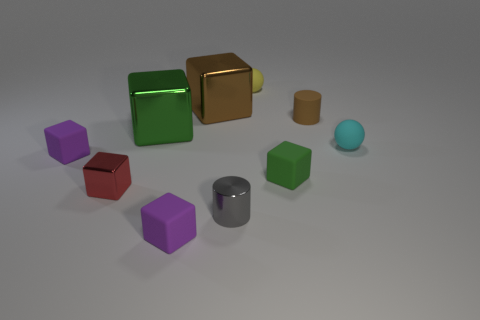Do the large green block and the cube to the right of the gray cylinder have the same material?
Provide a succinct answer. No. Are there more small purple rubber objects than small yellow rubber spheres?
Offer a terse response. Yes. What number of cylinders are tiny red metal objects or small things?
Provide a short and direct response. 2. The tiny metallic block is what color?
Provide a short and direct response. Red. There is a shiny object that is on the right side of the big brown metallic block; does it have the same size as the purple rubber cube that is behind the small red cube?
Ensure brevity in your answer.  Yes. Is the number of big blocks less than the number of tiny metal blocks?
Provide a short and direct response. No. There is a brown matte object; how many tiny purple matte objects are behind it?
Offer a terse response. 0. What is the large green block made of?
Ensure brevity in your answer.  Metal. Is the color of the small metal block the same as the small metallic cylinder?
Your answer should be very brief. No. Are there fewer big brown metallic objects that are on the left side of the metallic cylinder than small cyan matte objects?
Offer a very short reply. No. 